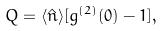Convert formula to latex. <formula><loc_0><loc_0><loc_500><loc_500>Q = \langle \hat { n } \rangle [ g ^ { ( 2 ) } ( 0 ) - 1 ] ,</formula> 